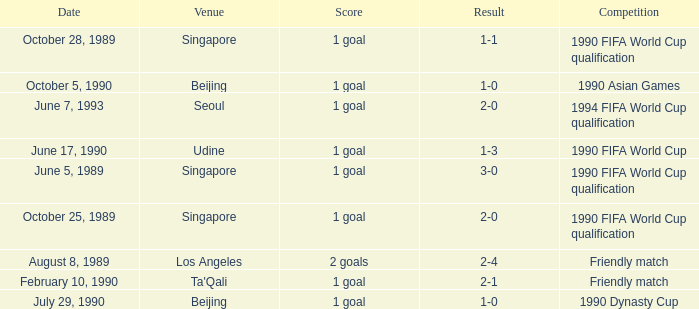What was the venue where the result was 2-1? Ta'Qali. 